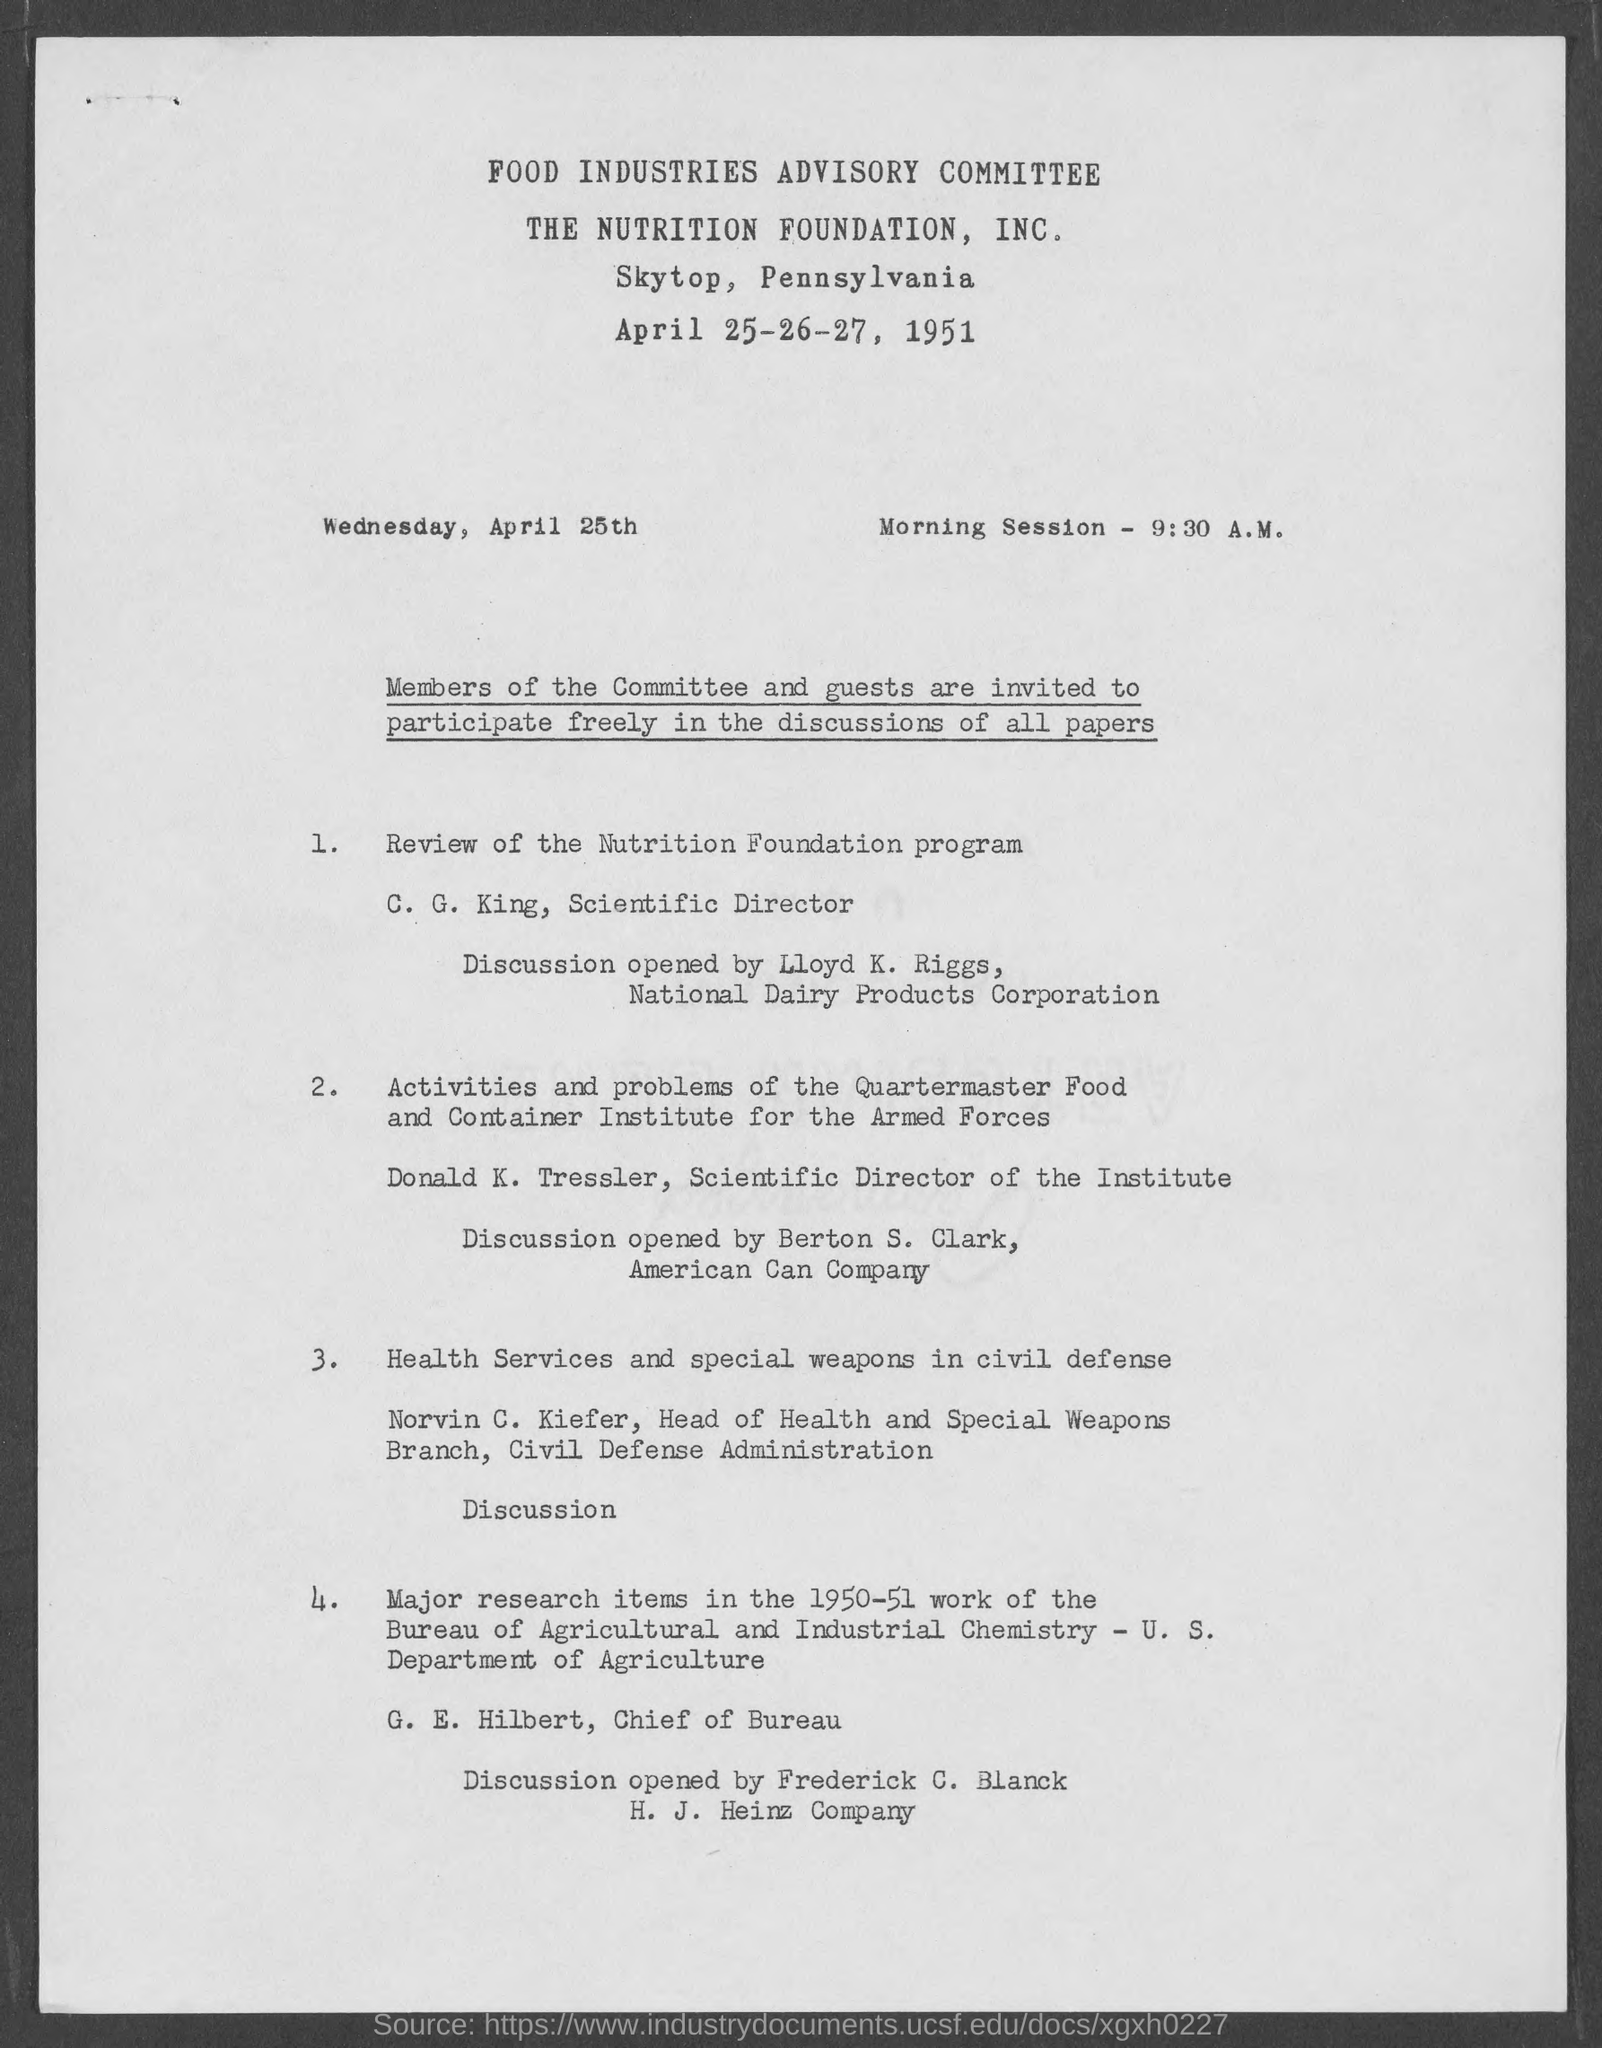Indicate a few pertinent items in this graphic. The Nutrition Foundation program is being reviewed by C.G. King. The program will take place in Skytop, Pennsylvania. The Food Industries Advisory Committee is mentioned. Donald K. Tressler is the Scientific Director of the Institute. Norvin C. Kiefer's topic is Health Services and Special Weapons in Civil Defense. 